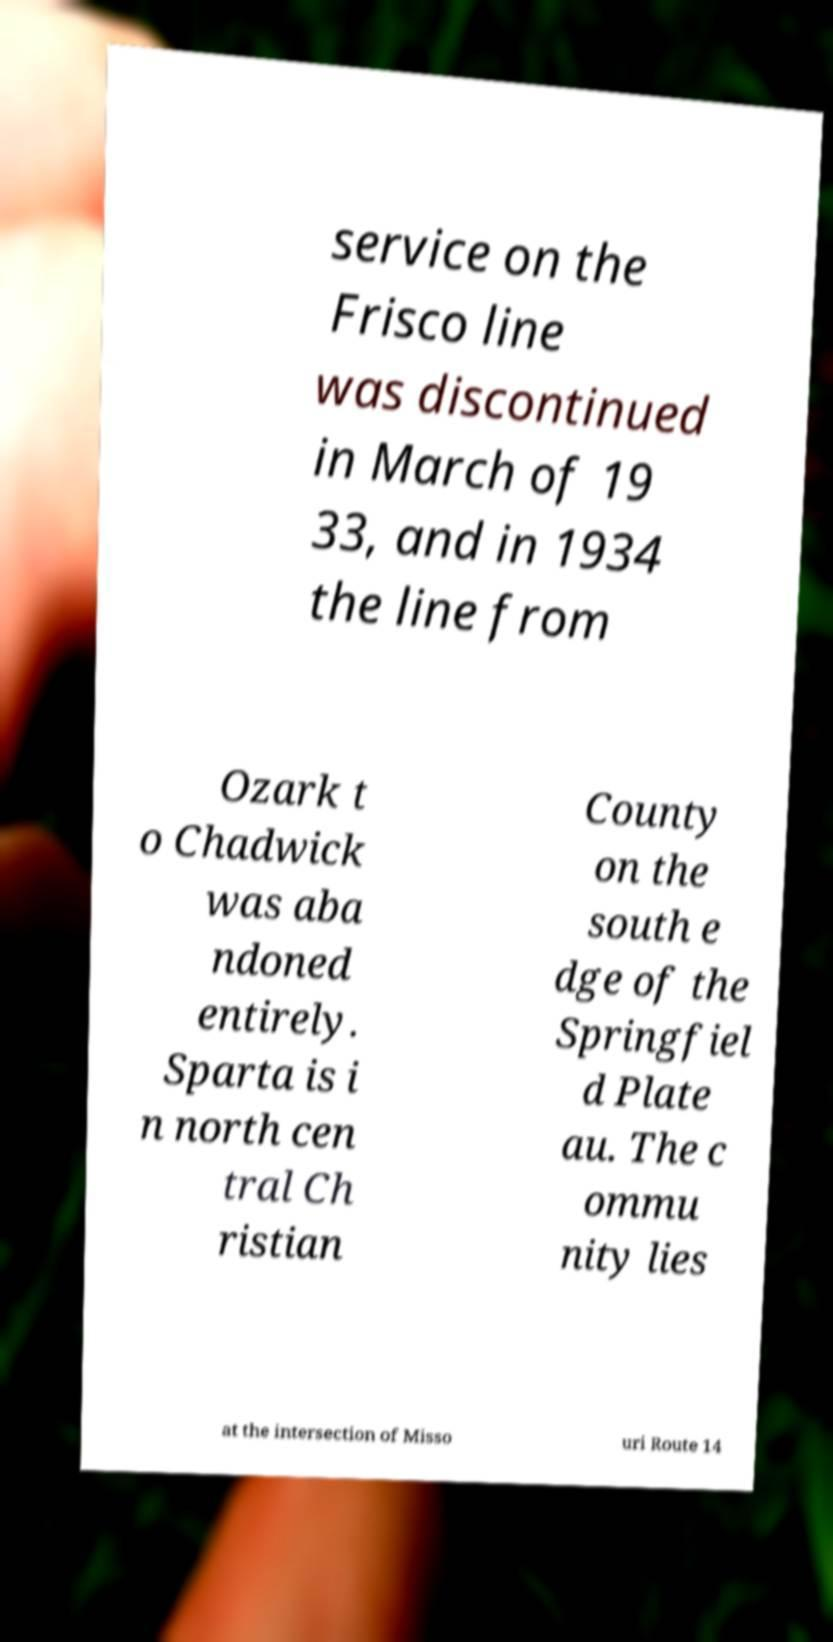Can you accurately transcribe the text from the provided image for me? service on the Frisco line was discontinued in March of 19 33, and in 1934 the line from Ozark t o Chadwick was aba ndoned entirely. Sparta is i n north cen tral Ch ristian County on the south e dge of the Springfiel d Plate au. The c ommu nity lies at the intersection of Misso uri Route 14 